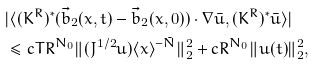<formula> <loc_0><loc_0><loc_500><loc_500>& | \langle ( K ^ { R } ) ^ { * } ( \vec { b } _ { 2 } ( x , t ) - \vec { b } _ { 2 } ( x , 0 ) ) \cdot \nabla \bar { u } , ( K ^ { R } ) ^ { * } \bar { u } \rangle | \\ & \leq c T R ^ { N _ { 0 } } \| ( J ^ { 1 / 2 } u ) \langle x \rangle ^ { - \tilde { N } } \| _ { 2 } ^ { 2 } + c R ^ { N _ { 0 } } \| u ( t ) \| _ { 2 } ^ { 2 } ,</formula> 